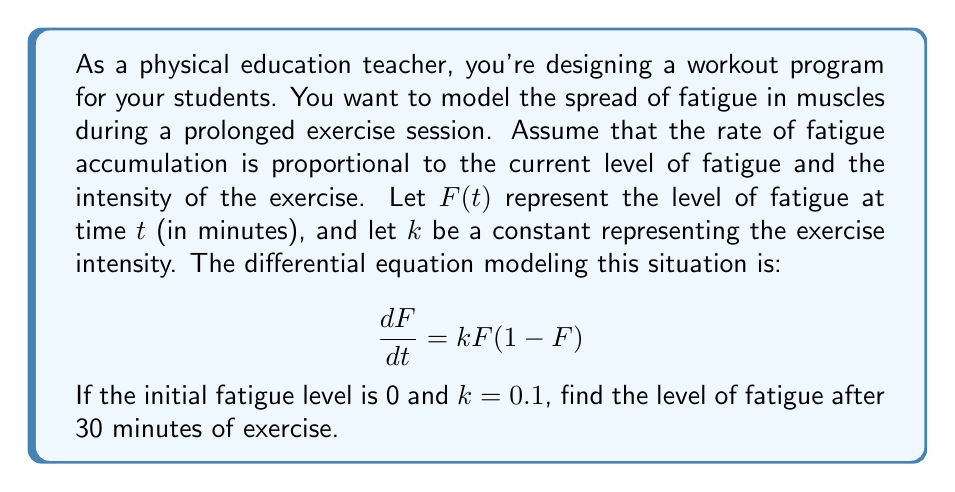Show me your answer to this math problem. To solve this problem, we need to follow these steps:

1) First, we recognize this differential equation as the logistic growth model:

   $$\frac{dF}{dt} = kF(1-F)$$

2) The solution to this equation is given by:

   $$F(t) = \frac{1}{1 + Ce^{-kt}}$$

   where $C$ is a constant determined by the initial condition.

3) We're given that the initial fatigue level is 0, so $F(0) = 0$. Let's use this to find $C$:

   $$0 = F(0) = \frac{1}{1 + C}$$

   Solving this, we get $C = \infty$ (technically, as $F(0)$ approaches 0, $C$ approaches infinity).

4) However, we can rewrite our solution in a more practical form:

   $$F(t) = \frac{e^{kt}}{e^{kt} + C}$$

5) Now, using $F(0) = 0$, we get:

   $$0 = \frac{e^{0}}{e^{0} + C} = \frac{1}{1 + C}$$

   This gives us $C = \infty$, or more practically, a very large number.

6) Our solution is now:

   $$F(t) = \frac{e^{kt}}{e^{kt} + C} = \frac{e^{kt} - 1}{e^{kt}}$$

7) We're given $k = 0.1$ and we need to find $F(30)$:

   $$F(30) = \frac{e^{0.1 * 30} - 1}{e^{0.1 * 30}} = \frac{e^3 - 1}{e^3}$$

8) Calculate this value:

   $$F(30) = \frac{20.0855 - 1}{20.0855} = 0.9502$$
Answer: The level of fatigue after 30 minutes of exercise is approximately 0.9502 or 95.02%. 